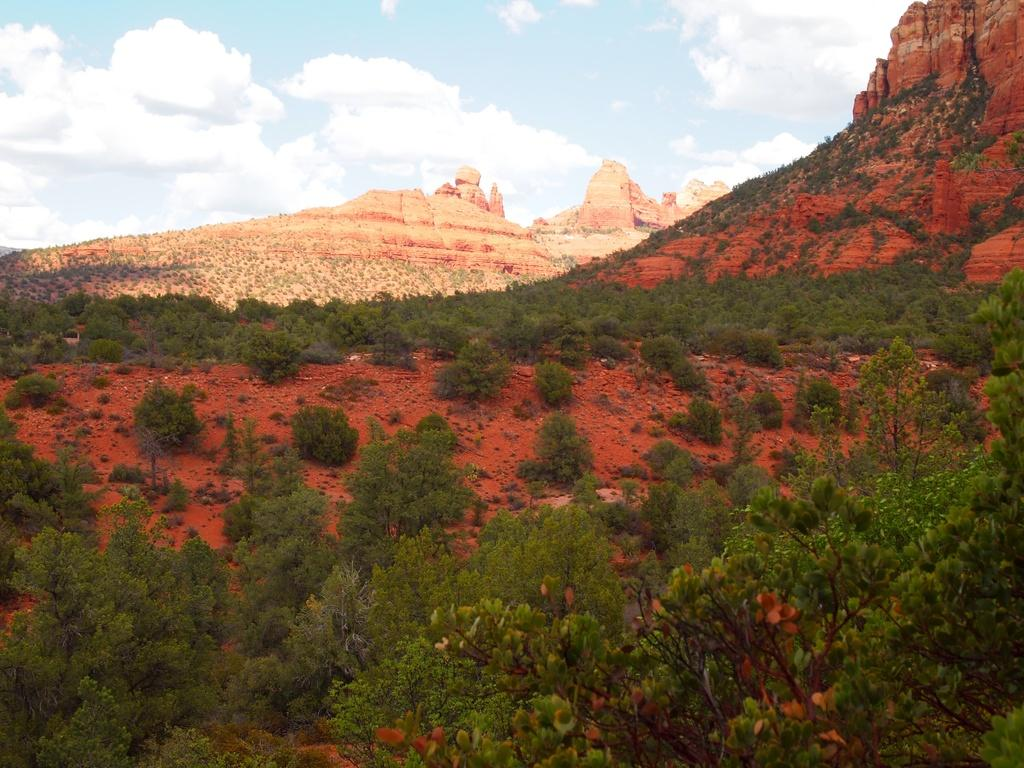What type of living organisms can be seen in the image? Plants and trees are visible in the image. What is the ground like in the image? The ground is visible in the image. What other natural elements can be seen in the image? There are rocks in the image. What is visible in the background of the image? The sky is visible in the background of the image. What can be seen in the sky? There are clouds in the sky. What type of meat is being grilled in the image? There is no meat or grill present in the image; it features plants, trees, ground, rocks, and the sky. 